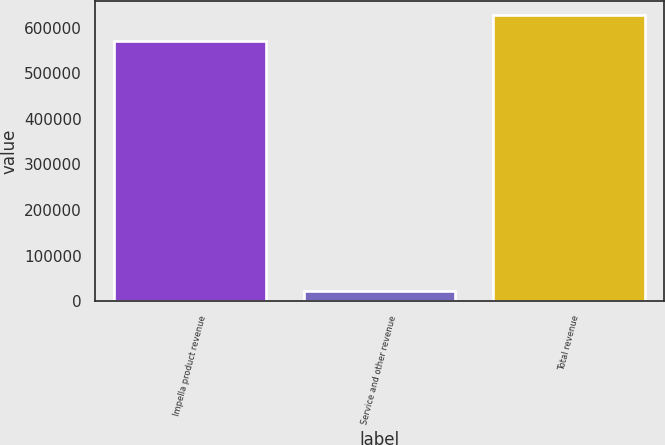Convert chart. <chart><loc_0><loc_0><loc_500><loc_500><bar_chart><fcel>Impella product revenue<fcel>Service and other revenue<fcel>Total revenue<nl><fcel>570870<fcel>22879<fcel>627957<nl></chart> 